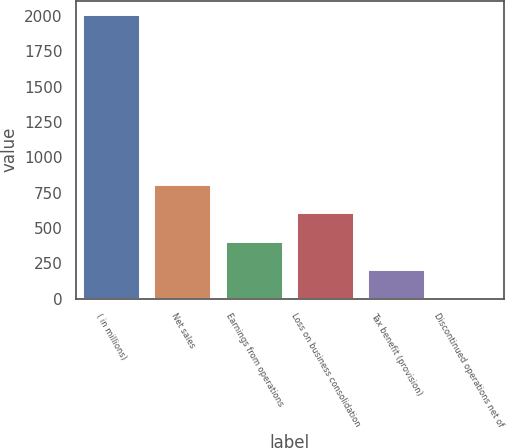Convert chart to OTSL. <chart><loc_0><loc_0><loc_500><loc_500><bar_chart><fcel>( in millions)<fcel>Net sales<fcel>Earnings from operations<fcel>Loss on business consolidation<fcel>Tax benefit (provision)<fcel>Discontinued operations net of<nl><fcel>2009<fcel>804.92<fcel>403.56<fcel>604.24<fcel>202.88<fcel>2.2<nl></chart> 